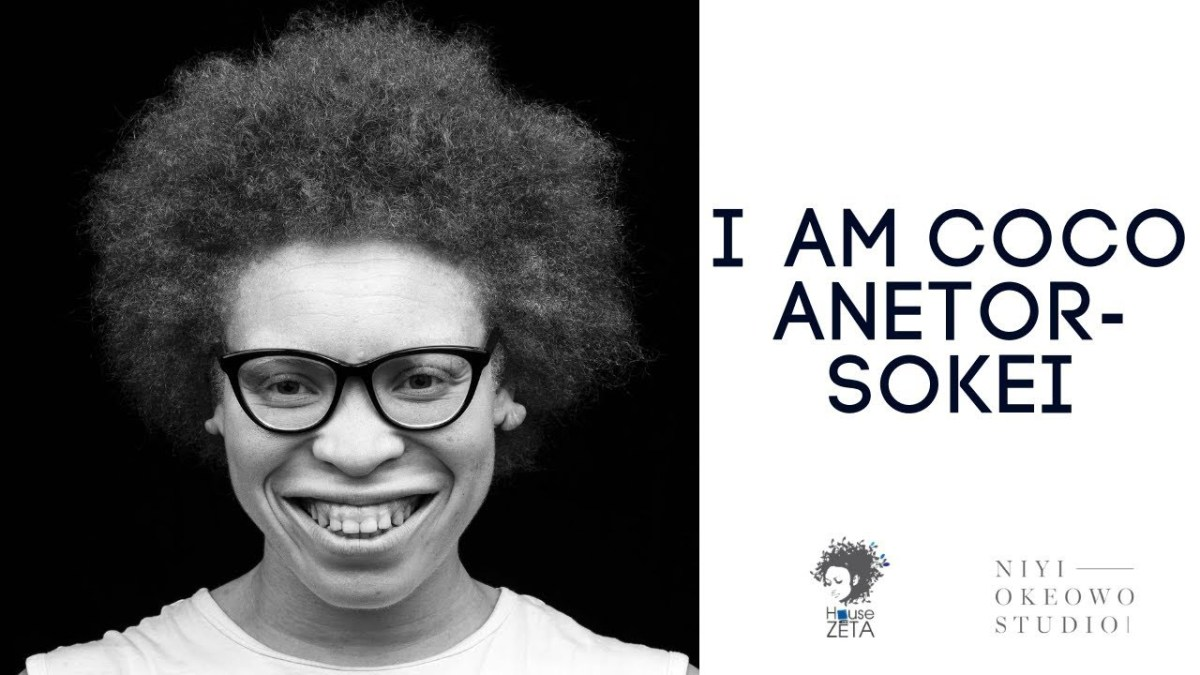What might the choice of black and white in the photograph signify about the artistic direction or message? The black and white palette in the photograph strips away the distractions of color, focusing on the raw emotional expression and intricate textures of Coco Anetor-Sokei's features. This choice often suggests a timelessness and a focus on the fundamental aspects of the subject, likely aiming to highlight authenticity and depth in the artistic message conveyed through this visual presentation. 